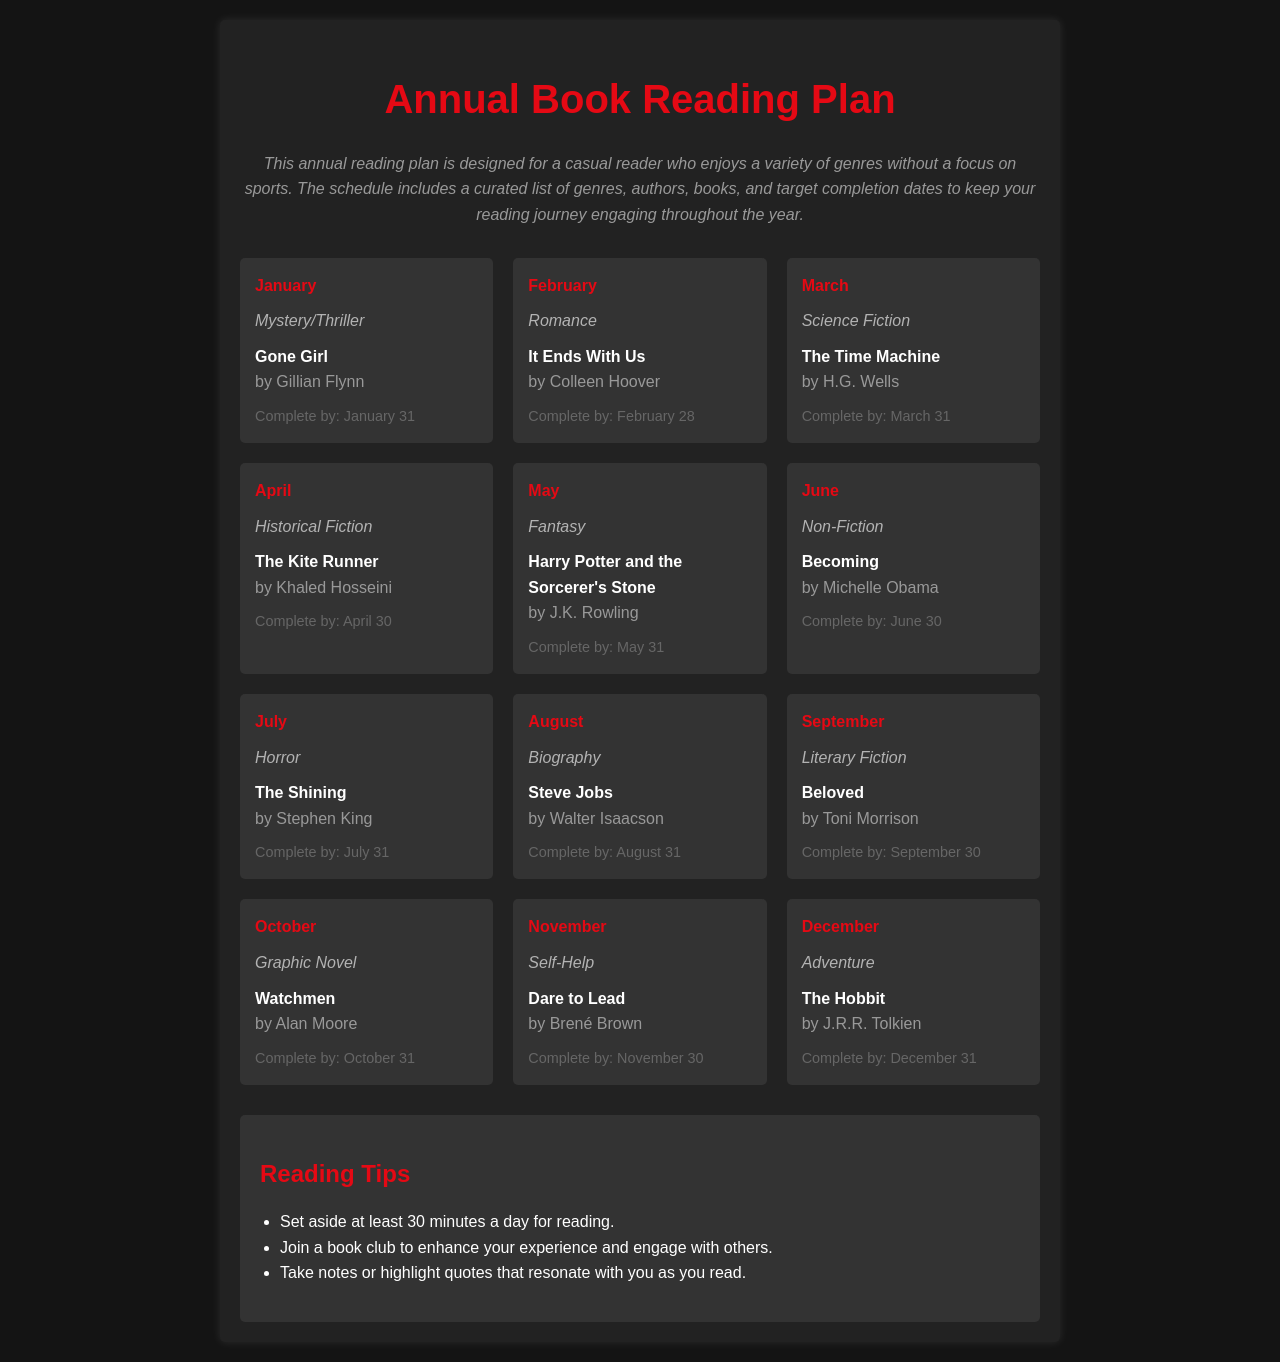What book is scheduled for January? The schedule lists "Gone Girl" by Gillian Flynn for January.
Answer: Gone Girl Who is the author of "The Kite Runner"? "The Kite Runner" is written by Khaled Hosseini.
Answer: Khaled Hosseini What genre is assigned to March's book? The genre for March is Science Fiction.
Answer: Science Fiction When is "Dare to Lead" expected to be completed? "Dare to Lead" should be complete by November 30.
Answer: November 30 Which month features a graphic novel? October has "Watchmen," which is a graphic novel.
Answer: October Name one reading tip provided in the document. One of the tips suggests to set aside at least 30 minutes a day for reading.
Answer: 30 minutes How many months contain a book related to fiction? There are six months with books related to fiction.
Answer: Six Which book is categorized as horror? The horror genre book listed is "The Shining."
Answer: The Shining What is the completion date for "The Hobbit"? "The Hobbit" is expected to be completed by December 31.
Answer: December 31 